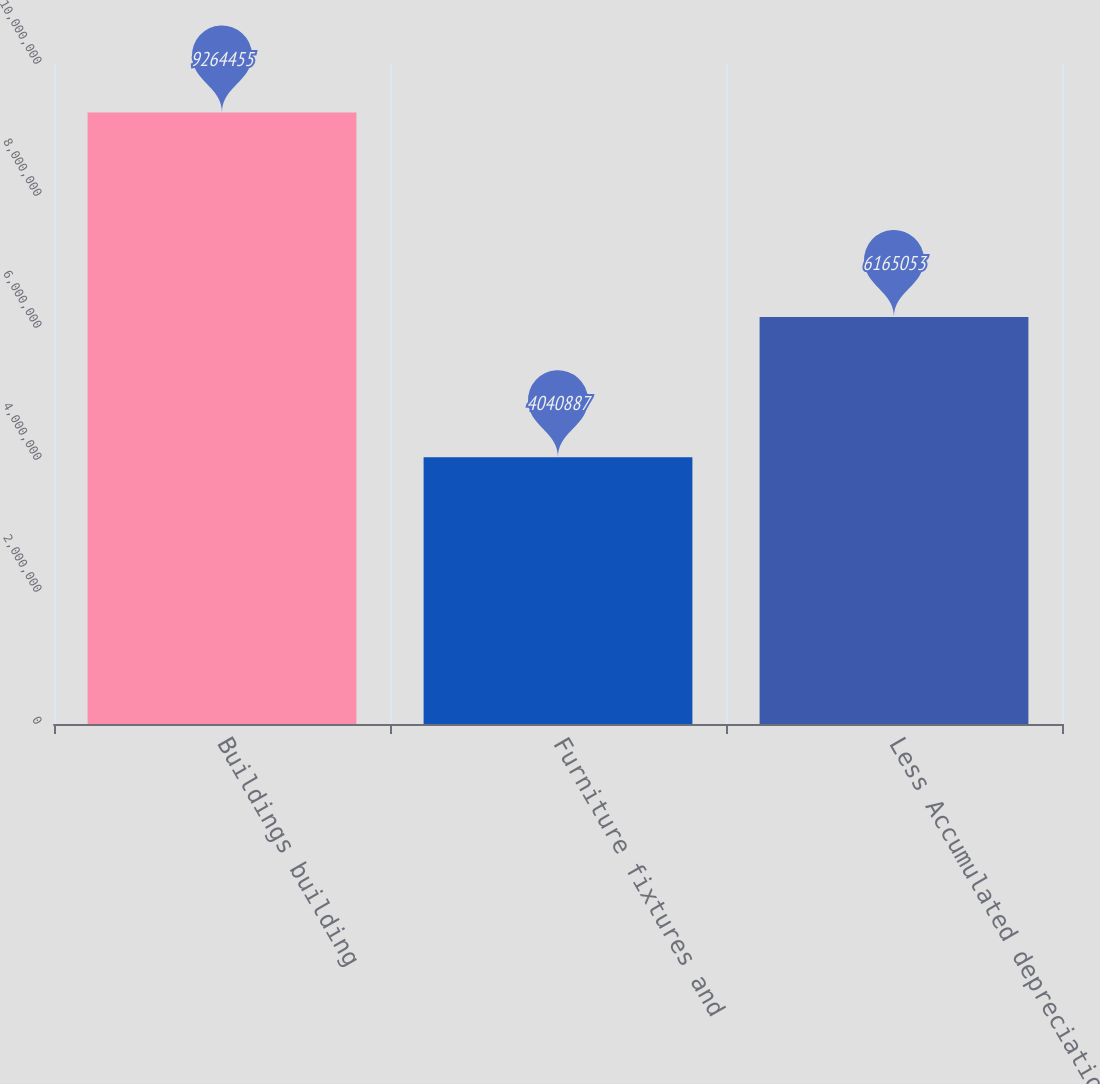Convert chart to OTSL. <chart><loc_0><loc_0><loc_500><loc_500><bar_chart><fcel>Buildings building<fcel>Furniture fixtures and<fcel>Less Accumulated depreciation<nl><fcel>9.26446e+06<fcel>4.04089e+06<fcel>6.16505e+06<nl></chart> 